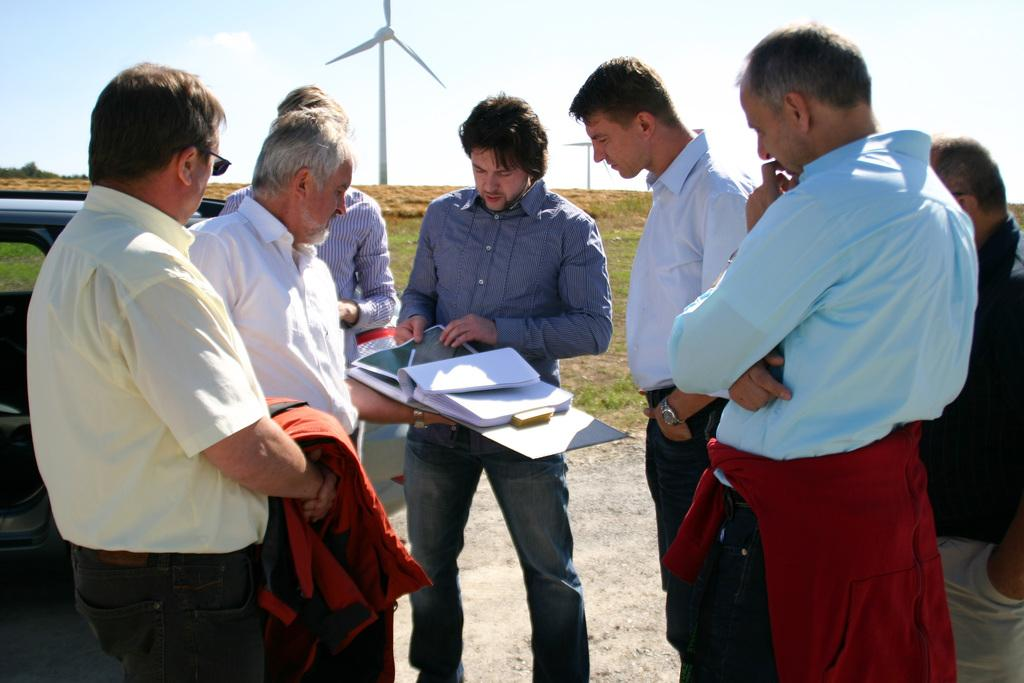What is the main subject of the image? The main subject of the image is a group of men. What are some of the men doing in the image? Some of the men are holding objects in their hands. What can be seen in the background of the image? There is a vehicle, windmills, grass, and the sky visible in the background of the image. What type of zinc is being used to construct the windmills in the image? There is no mention of zinc or any construction materials in the image. The windmills are simply visible in the background. Can you hear the bell ringing in the image? There is no bell present in the image, so it is not possible to hear it ringing. 